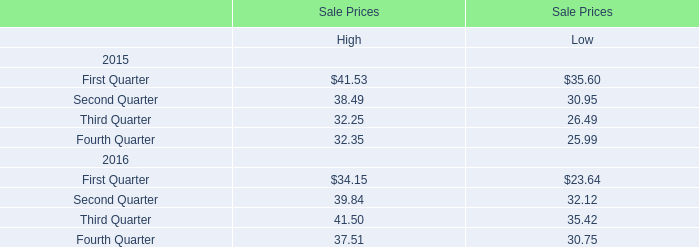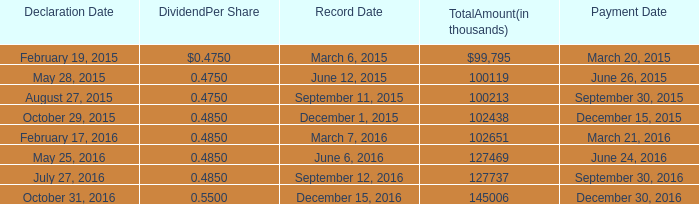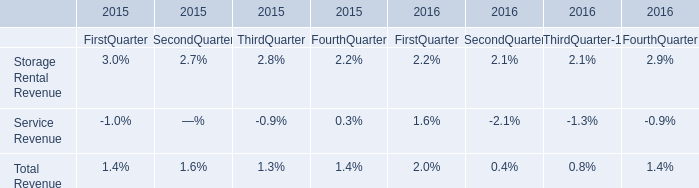What's the increasing rate of High for Sale Prices in Third Quarter in 2016? 
Computations: ((41.50 - 32.25) / 32.25)
Answer: 0.28682. 